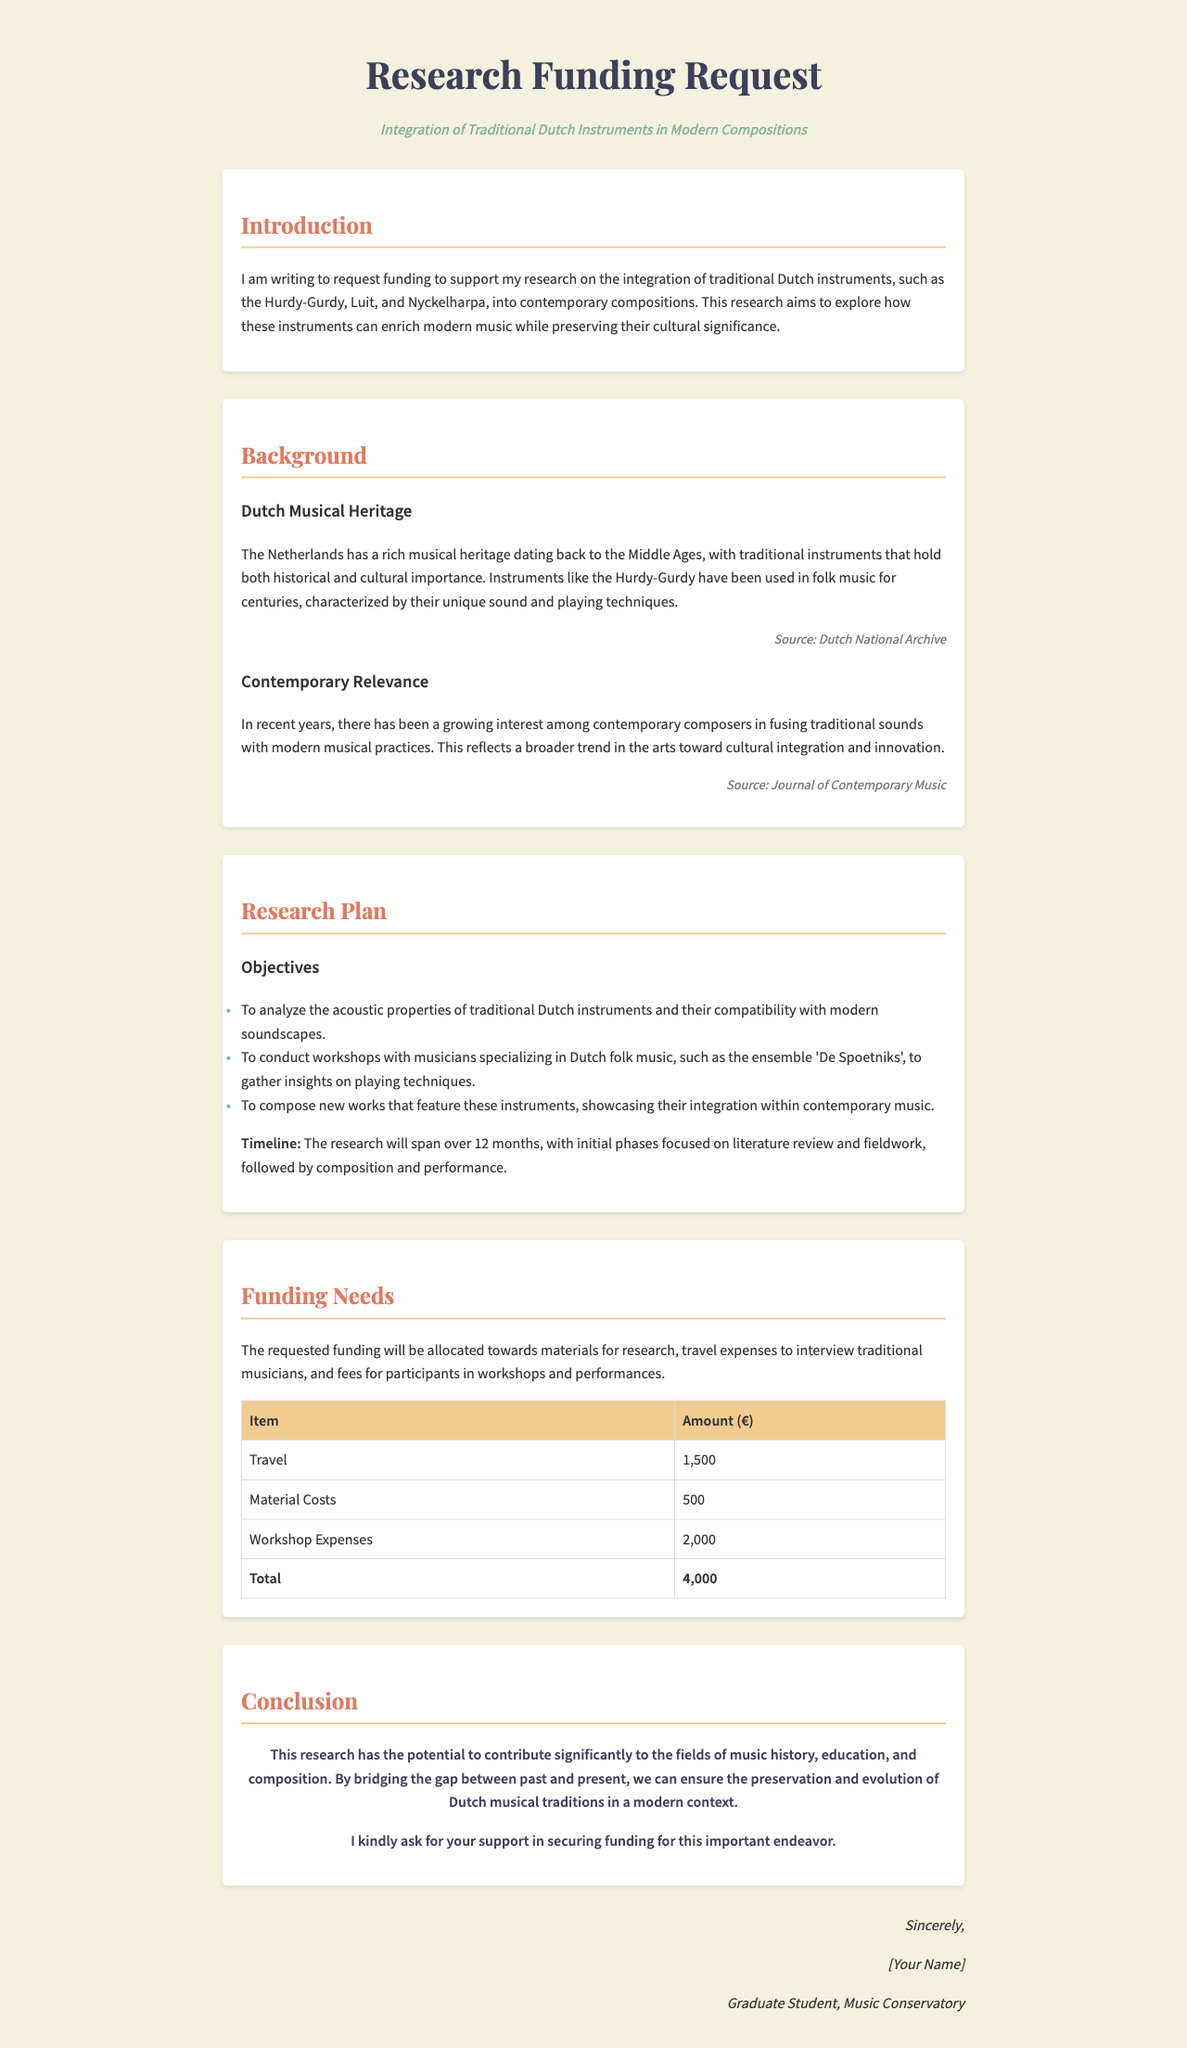What is the title of the research funding request? The title is stated at the top of the document as "Research Funding Request."
Answer: Research Funding Request What traditional Dutch instruments are mentioned? The instruments are explicitly listed in the introduction, which includes the Hurdy-Gurdy, Luit, and Nyckelharpa.
Answer: Hurdy-Gurdy, Luit, Nyckelharpa What is the total funding requested? The total amount is clearly outlined in the budget section, summing all requested items.
Answer: 4,000 How long will the research span? The timeline for the research is explicitly stated in the research plan section as 12 months.
Answer: 12 months What ensemble is mentioned for gathering insights on playing techniques? The specific ensemble noted for workshops in the document is 'De Spoetniks.'
Answer: De Spoetniks What is the first objective of the research? The first objective is listed in the research plan, which discusses analyzing acoustic properties.
Answer: To analyze the acoustic properties of traditional Dutch instruments Why is there a growing interest among contemporary composers? The document states that there is a trend toward cultural integration and innovation in the arts.
Answer: Cultural integration and innovation What type of document is this? The structure and purpose of the content indicate it is a funding request letter.
Answer: Funding request letter 